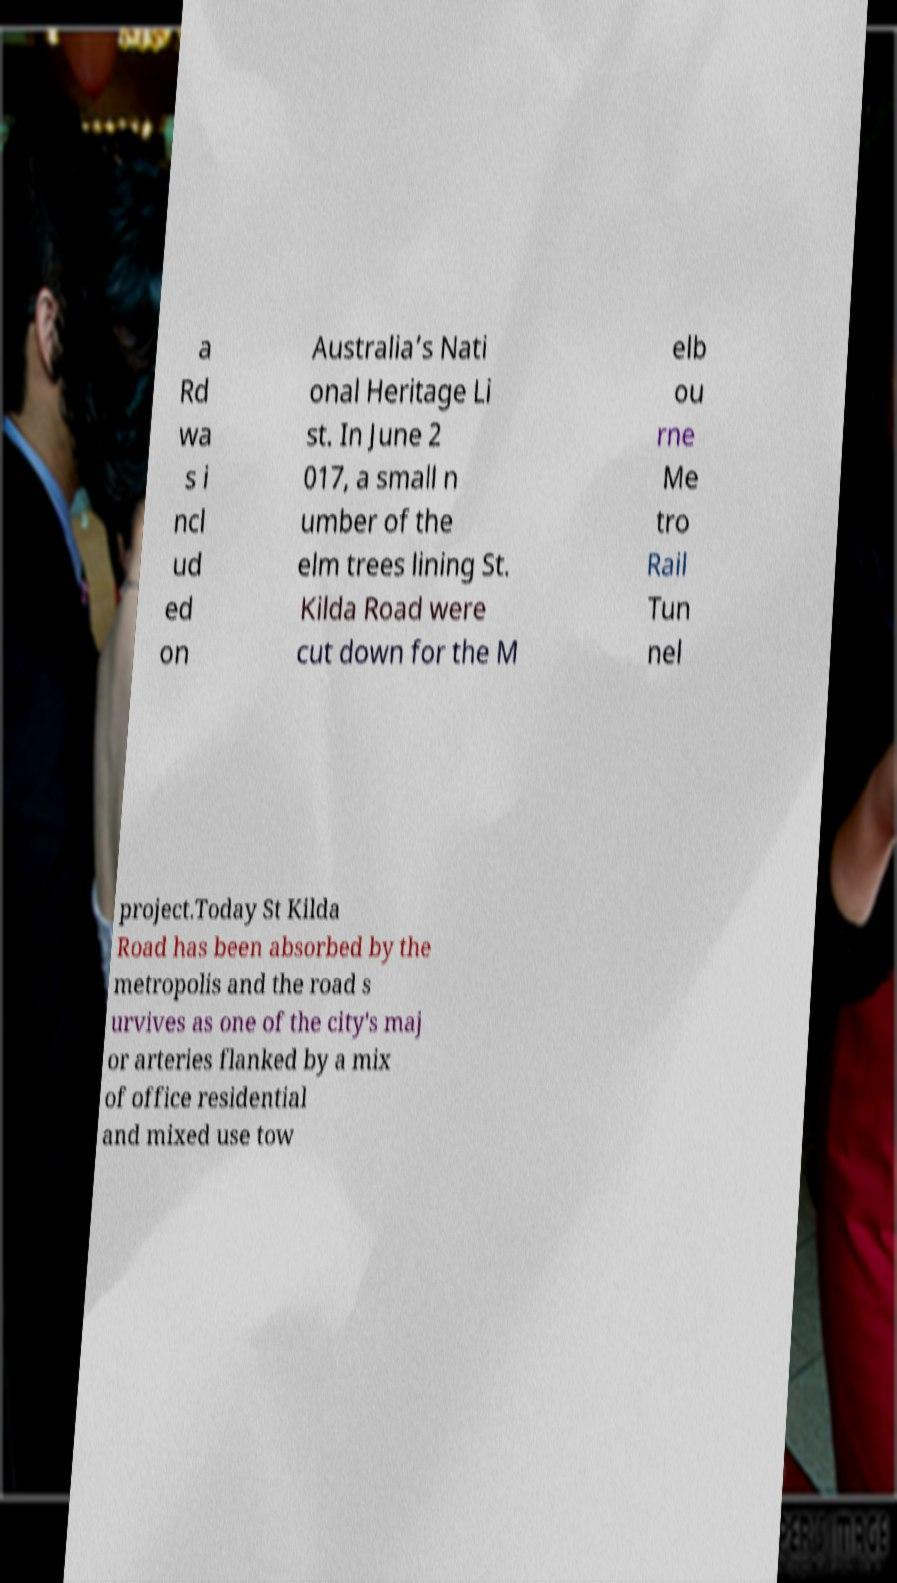Please identify and transcribe the text found in this image. a Rd wa s i ncl ud ed on Australia’s Nati onal Heritage Li st. In June 2 017, a small n umber of the elm trees lining St. Kilda Road were cut down for the M elb ou rne Me tro Rail Tun nel project.Today St Kilda Road has been absorbed by the metropolis and the road s urvives as one of the city's maj or arteries flanked by a mix of office residential and mixed use tow 